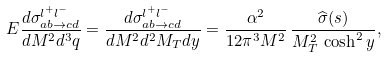Convert formula to latex. <formula><loc_0><loc_0><loc_500><loc_500>E \frac { d \sigma _ { a b \rightarrow c d } ^ { l ^ { + } l ^ { - } } } { d M ^ { 2 } d ^ { 3 } q } = \frac { d \sigma _ { a b \rightarrow c d } ^ { l ^ { + } l ^ { - } } } { d M ^ { 2 } d ^ { 2 } M _ { T } d y } = \frac { \alpha ^ { 2 } } { 1 2 \pi ^ { 3 } M ^ { 2 } } \, \frac { \widehat { \sigma } ( s ) } { M _ { T } ^ { 2 } \, \cosh ^ { 2 } y } ,</formula> 